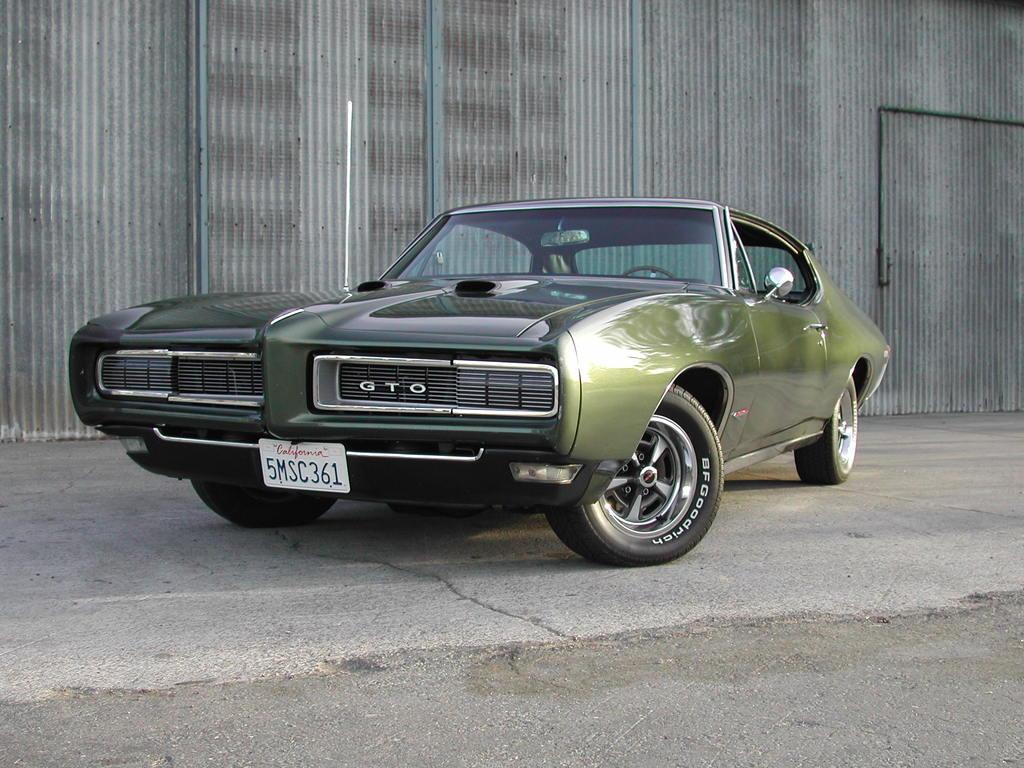What is the main subject of the image? The main subject of the image is a car on the road. Can you describe any additional features in the background of the image? Yes, there is a pipe attached to a metal sheet in the background of the image. What type of band is performing on the car in the image? There is no band present in the image; it only features a car on the road and a pipe attached to a metal sheet in the background. 